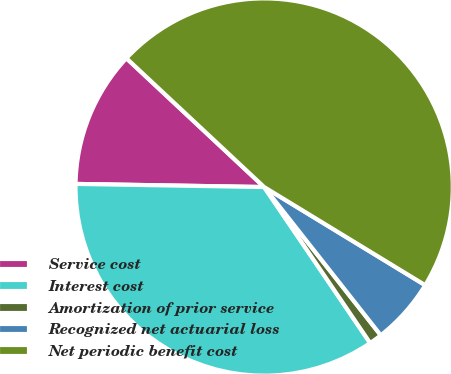Convert chart to OTSL. <chart><loc_0><loc_0><loc_500><loc_500><pie_chart><fcel>Service cost<fcel>Interest cost<fcel>Amortization of prior service<fcel>Recognized net actuarial loss<fcel>Net periodic benefit cost<nl><fcel>11.7%<fcel>34.76%<fcel>1.11%<fcel>5.68%<fcel>46.74%<nl></chart> 